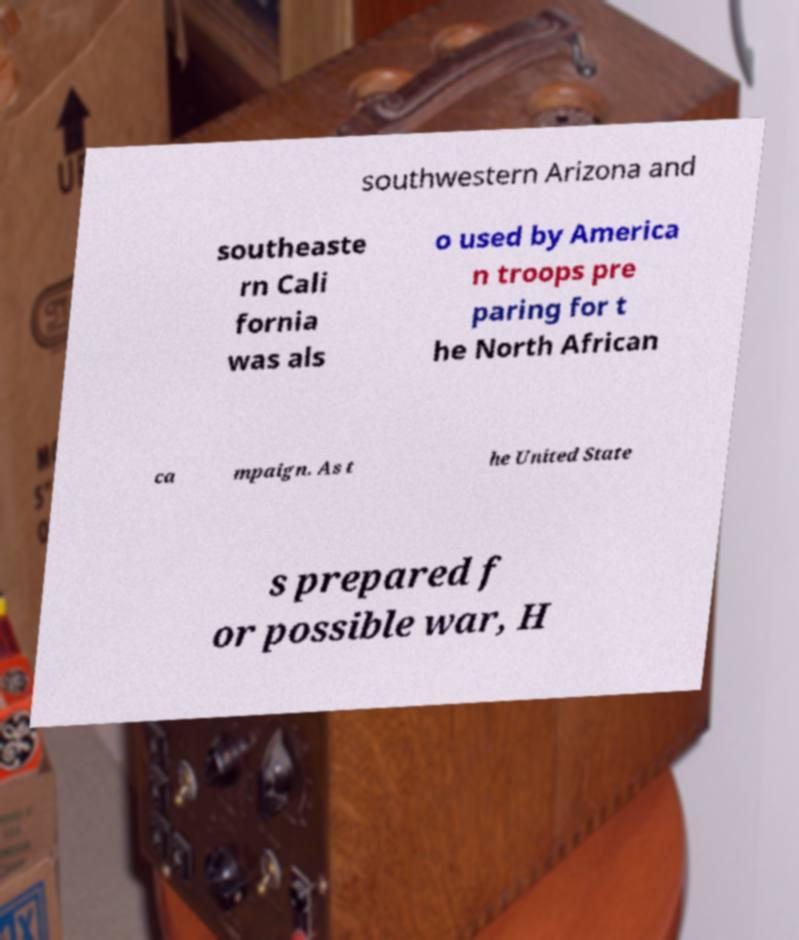Please identify and transcribe the text found in this image. southwestern Arizona and southeaste rn Cali fornia was als o used by America n troops pre paring for t he North African ca mpaign. As t he United State s prepared f or possible war, H 